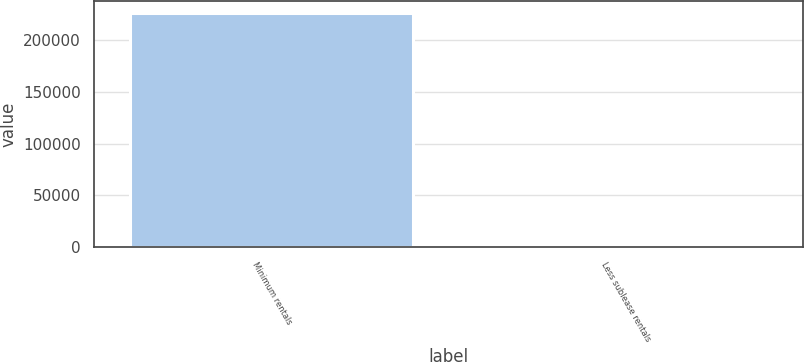Convert chart to OTSL. <chart><loc_0><loc_0><loc_500><loc_500><bar_chart><fcel>Minimum rentals<fcel>Less sublease rentals<nl><fcel>226787<fcel>2636<nl></chart> 